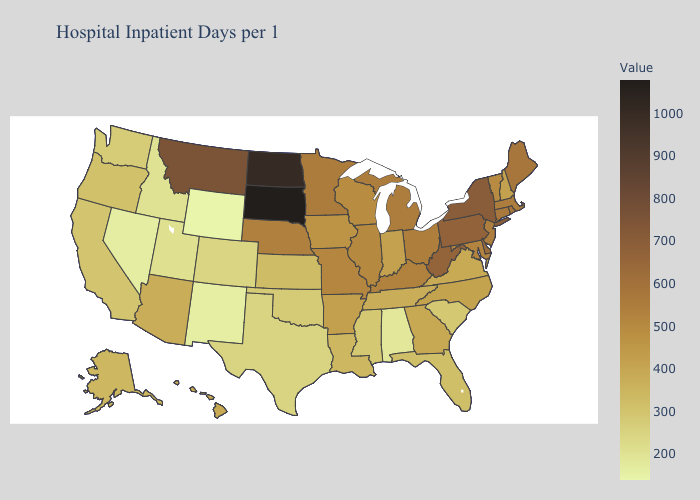Does West Virginia have the highest value in the South?
Short answer required. Yes. Among the states that border Washington , which have the lowest value?
Answer briefly. Idaho. 